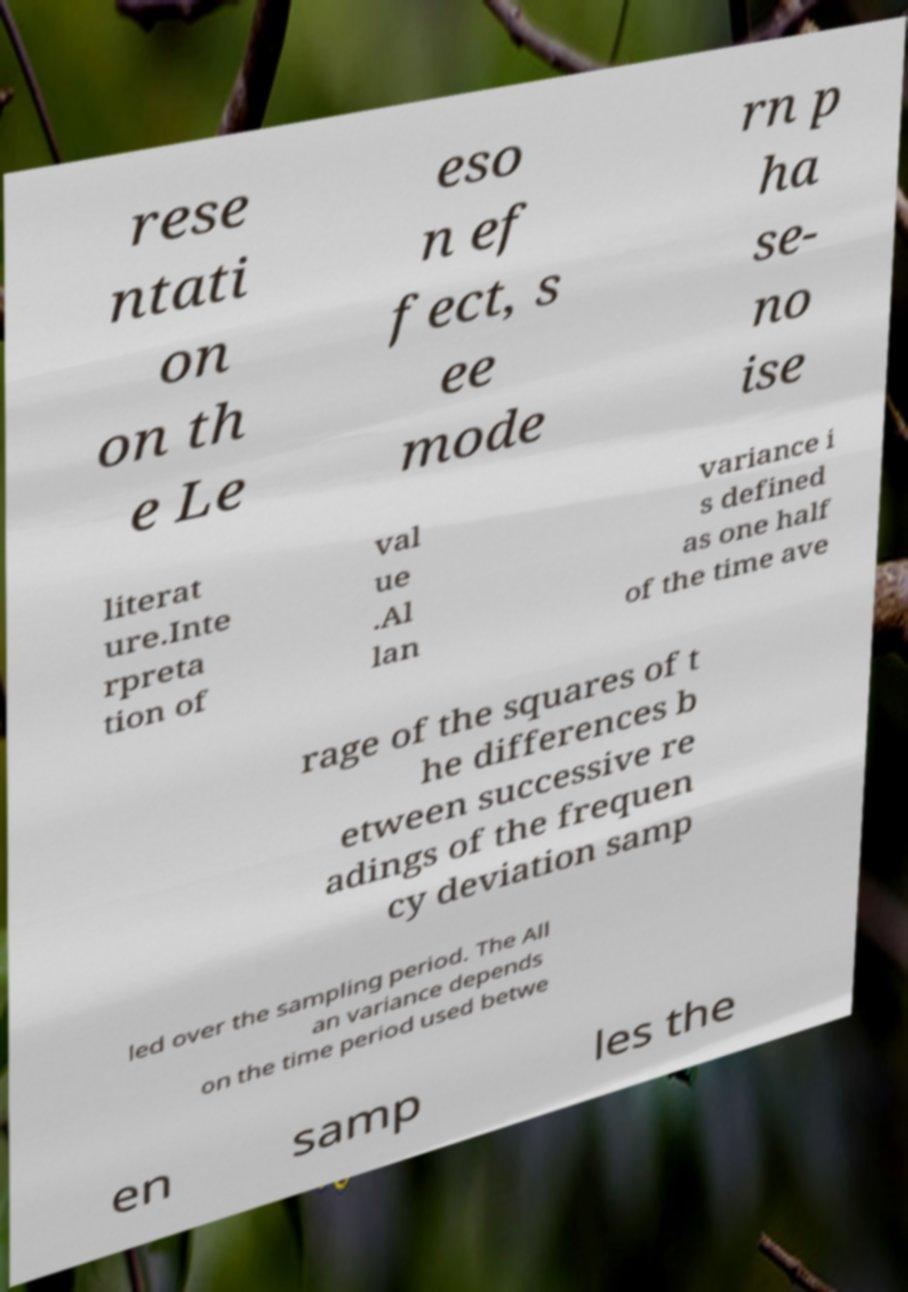I need the written content from this picture converted into text. Can you do that? rese ntati on on th e Le eso n ef fect, s ee mode rn p ha se- no ise literat ure.Inte rpreta tion of val ue .Al lan variance i s defined as one half of the time ave rage of the squares of t he differences b etween successive re adings of the frequen cy deviation samp led over the sampling period. The All an variance depends on the time period used betwe en samp les the 